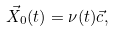Convert formula to latex. <formula><loc_0><loc_0><loc_500><loc_500>\vec { X } _ { 0 } ( t ) = \nu ( t ) \vec { c } ,</formula> 